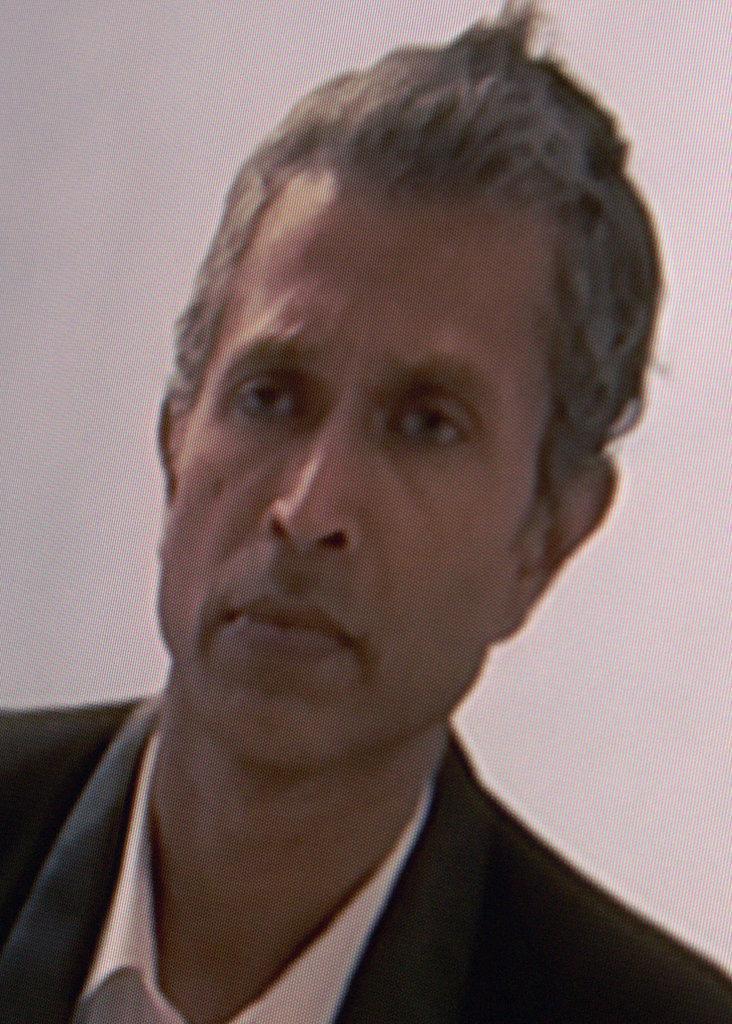In one or two sentences, can you explain what this image depicts? In this picture, we see a man is wearing the white shirt and the black blazer. He is looking at something. In the background, it is white in color and it might be a wall. This might be an edited image. 